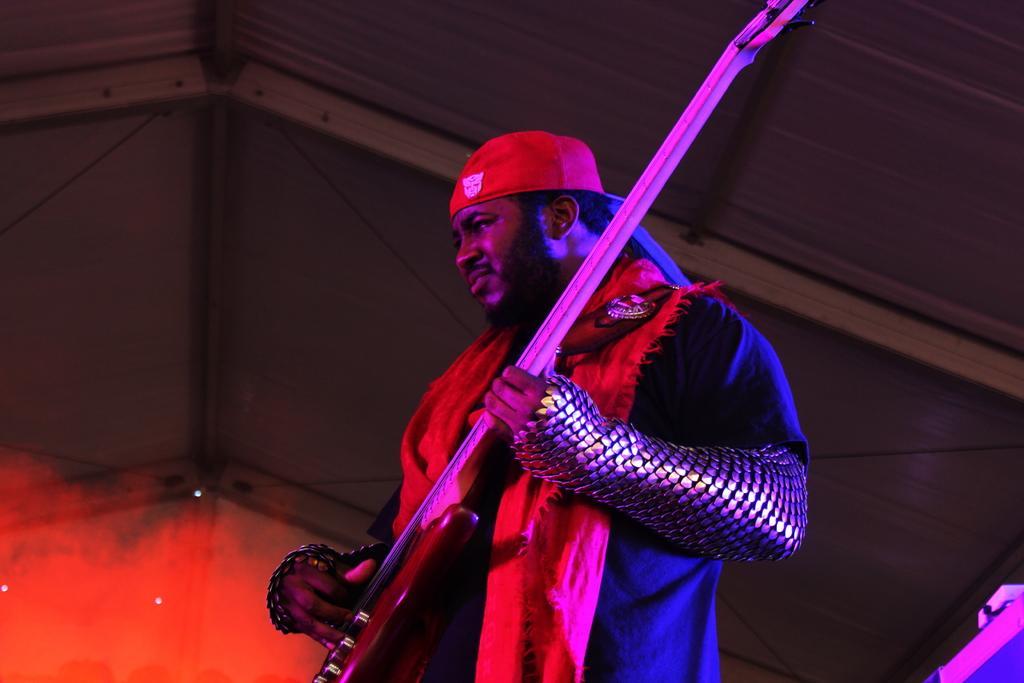Please provide a concise description of this image. In this image we can see a person holding a guitar. In the background there is a roof. 